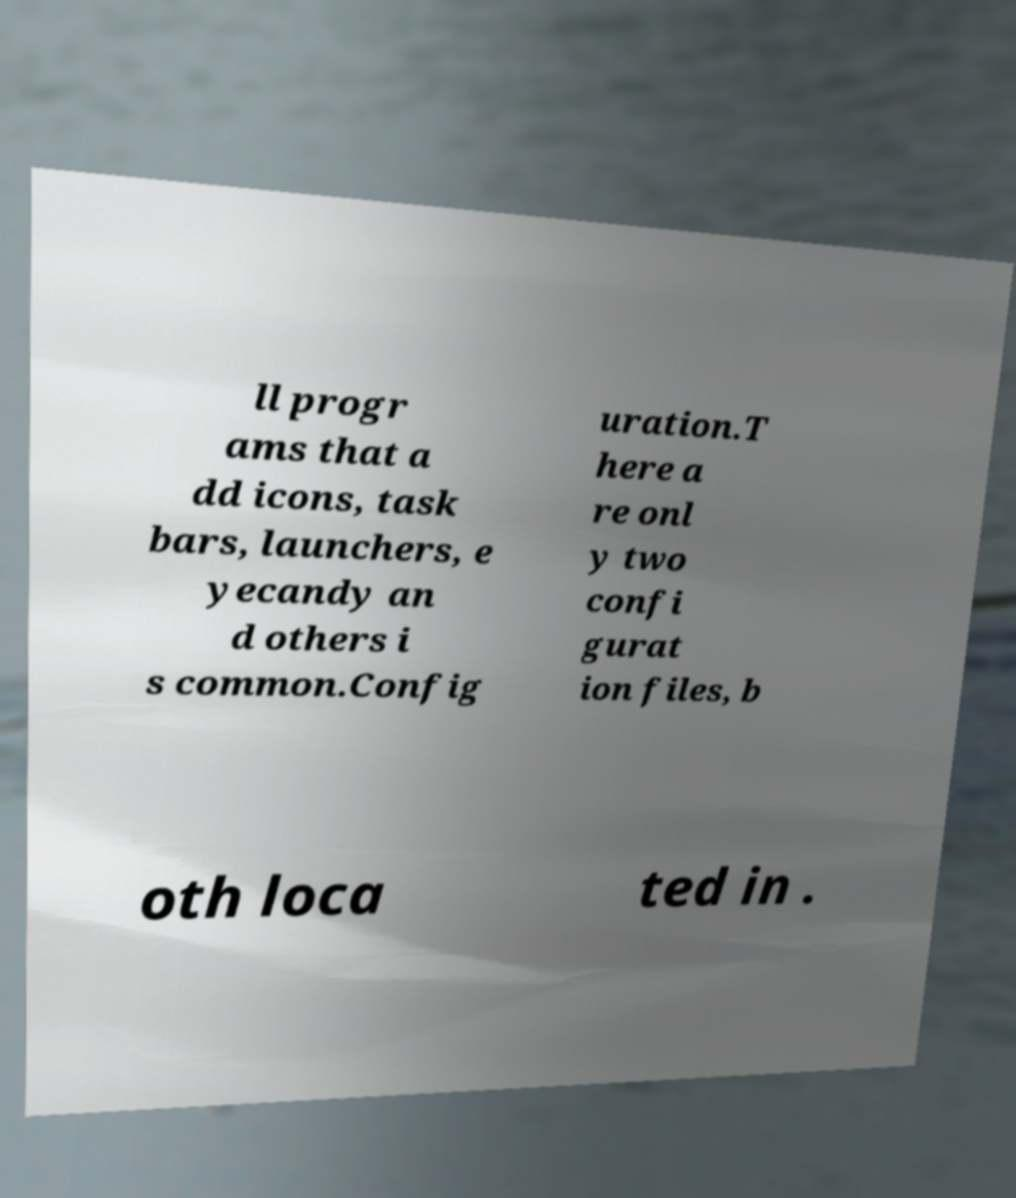Can you read and provide the text displayed in the image?This photo seems to have some interesting text. Can you extract and type it out for me? ll progr ams that a dd icons, task bars, launchers, e yecandy an d others i s common.Config uration.T here a re onl y two confi gurat ion files, b oth loca ted in . 